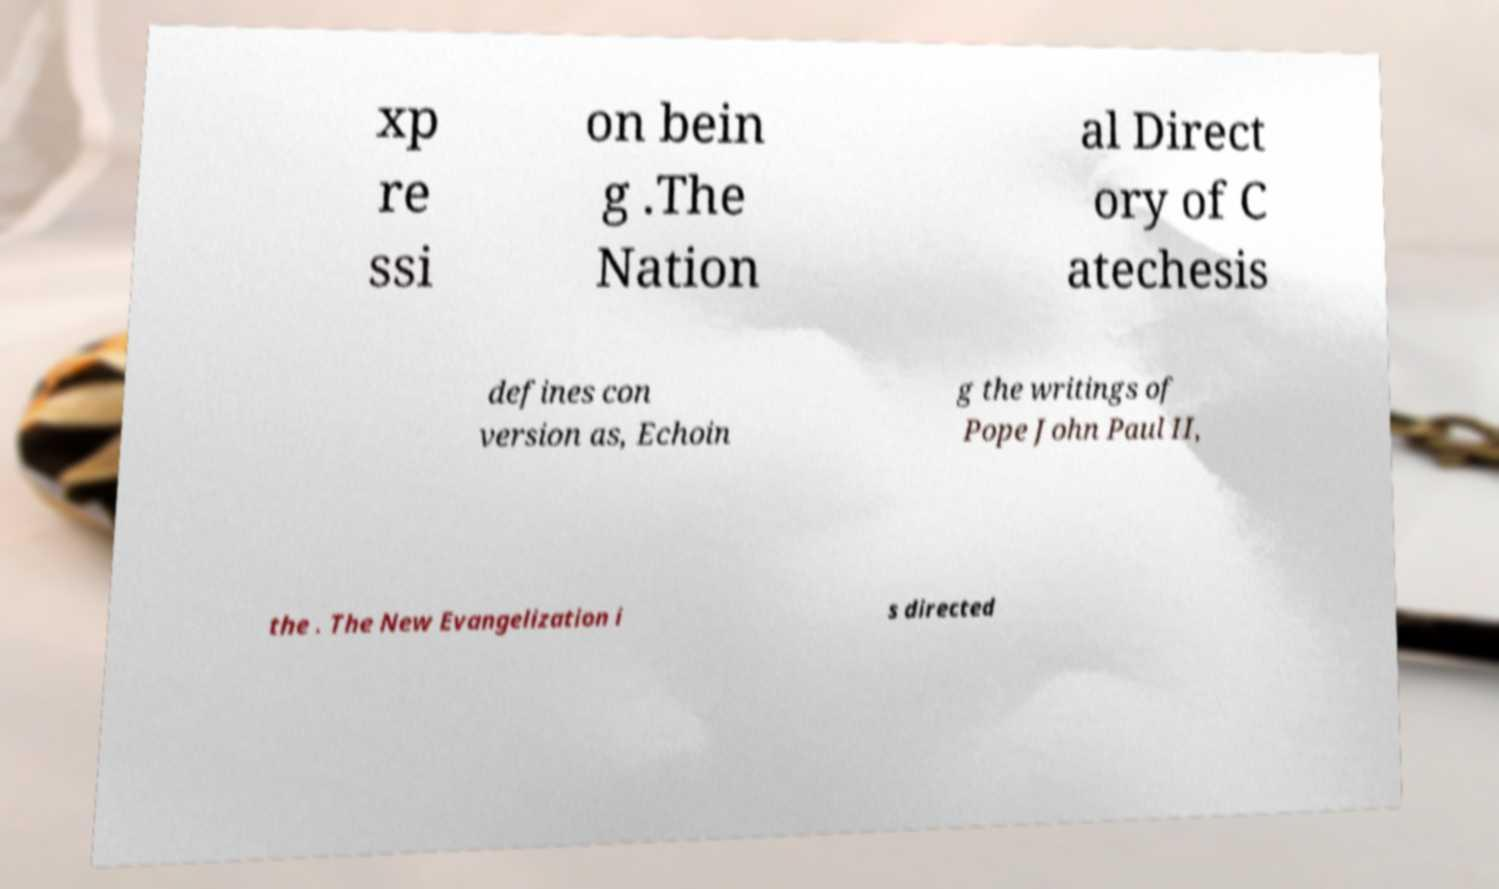Please identify and transcribe the text found in this image. xp re ssi on bein g .The Nation al Direct ory of C atechesis defines con version as, Echoin g the writings of Pope John Paul II, the . The New Evangelization i s directed 